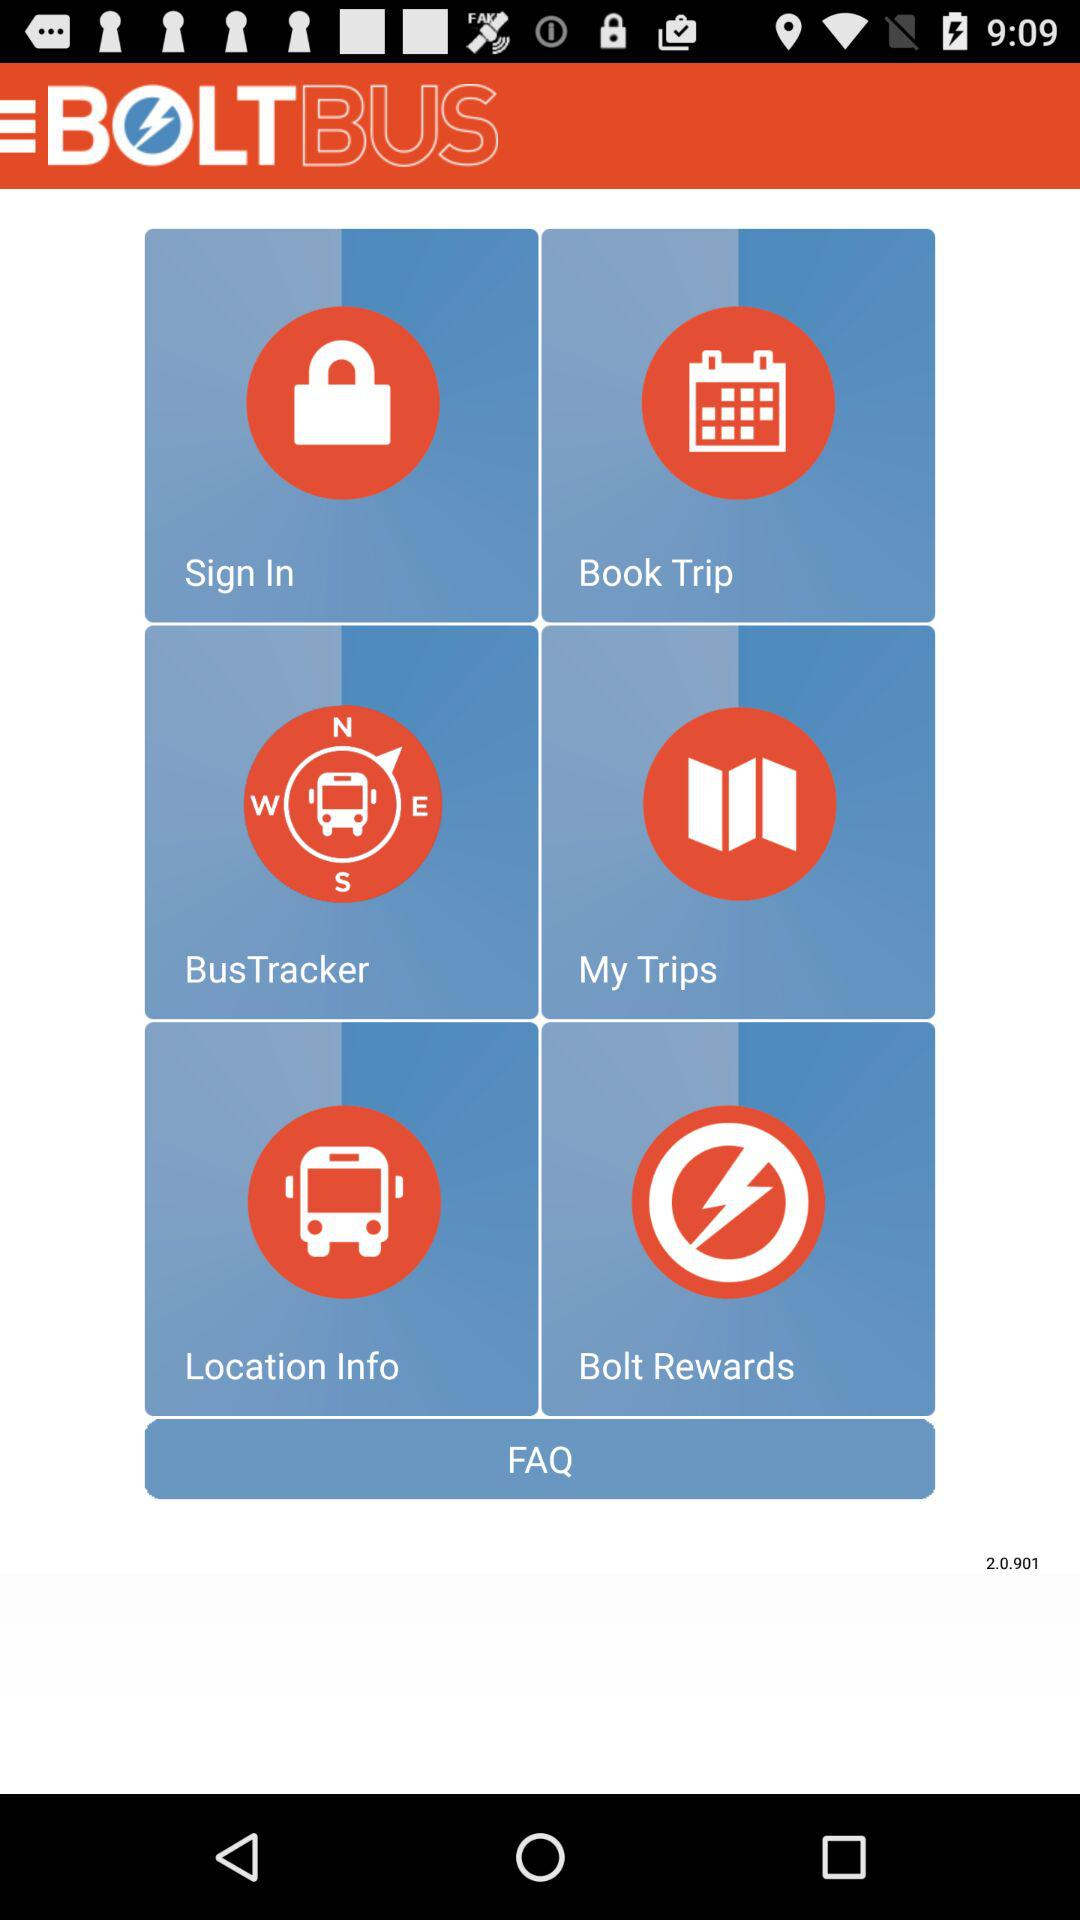What is the app name? The app name is "BOLTBUS". 